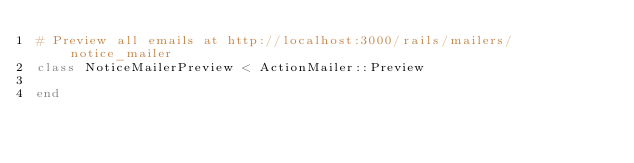<code> <loc_0><loc_0><loc_500><loc_500><_Ruby_># Preview all emails at http://localhost:3000/rails/mailers/notice_mailer
class NoticeMailerPreview < ActionMailer::Preview

end
</code> 